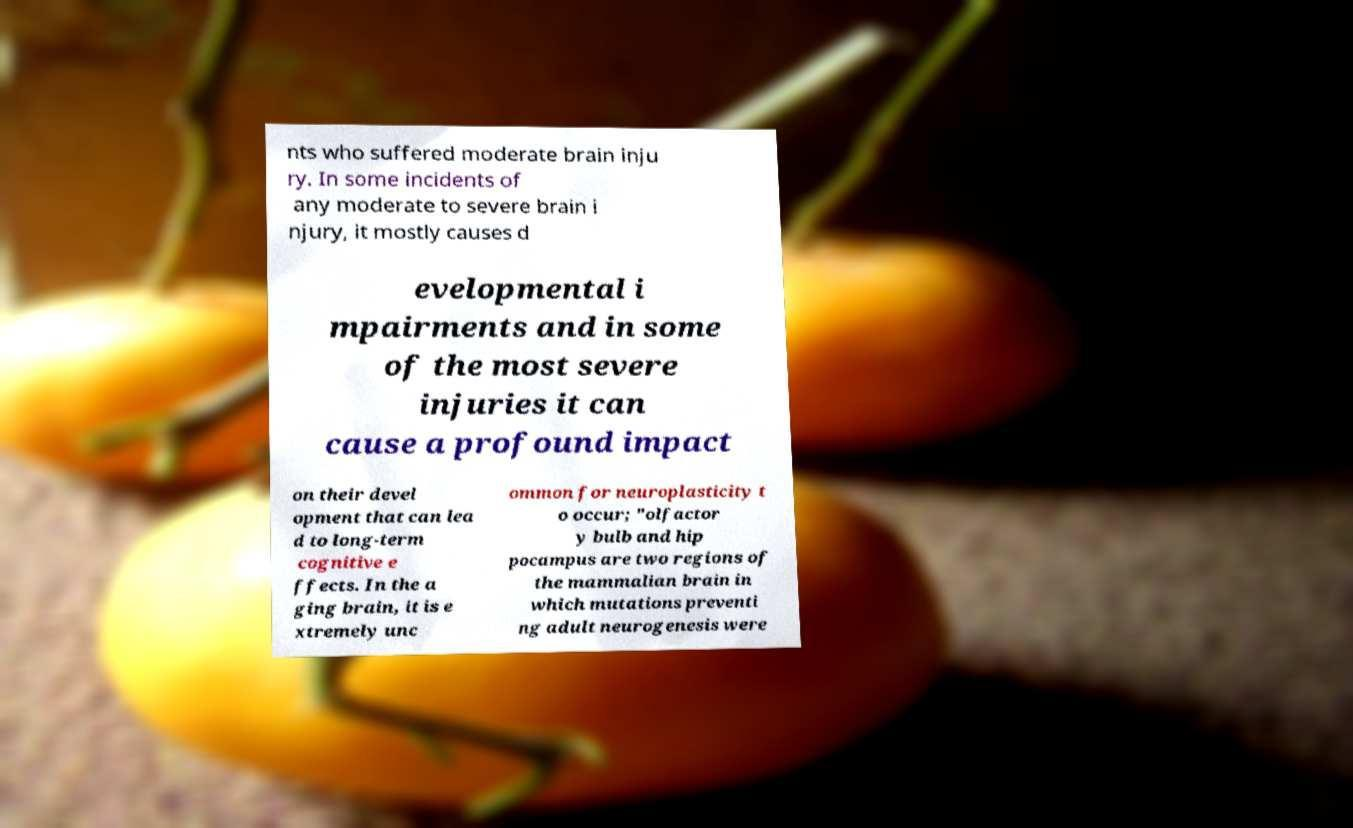Can you read and provide the text displayed in the image?This photo seems to have some interesting text. Can you extract and type it out for me? nts who suffered moderate brain inju ry. In some incidents of any moderate to severe brain i njury, it mostly causes d evelopmental i mpairments and in some of the most severe injuries it can cause a profound impact on their devel opment that can lea d to long-term cognitive e ffects. In the a ging brain, it is e xtremely unc ommon for neuroplasticity t o occur; "olfactor y bulb and hip pocampus are two regions of the mammalian brain in which mutations preventi ng adult neurogenesis were 